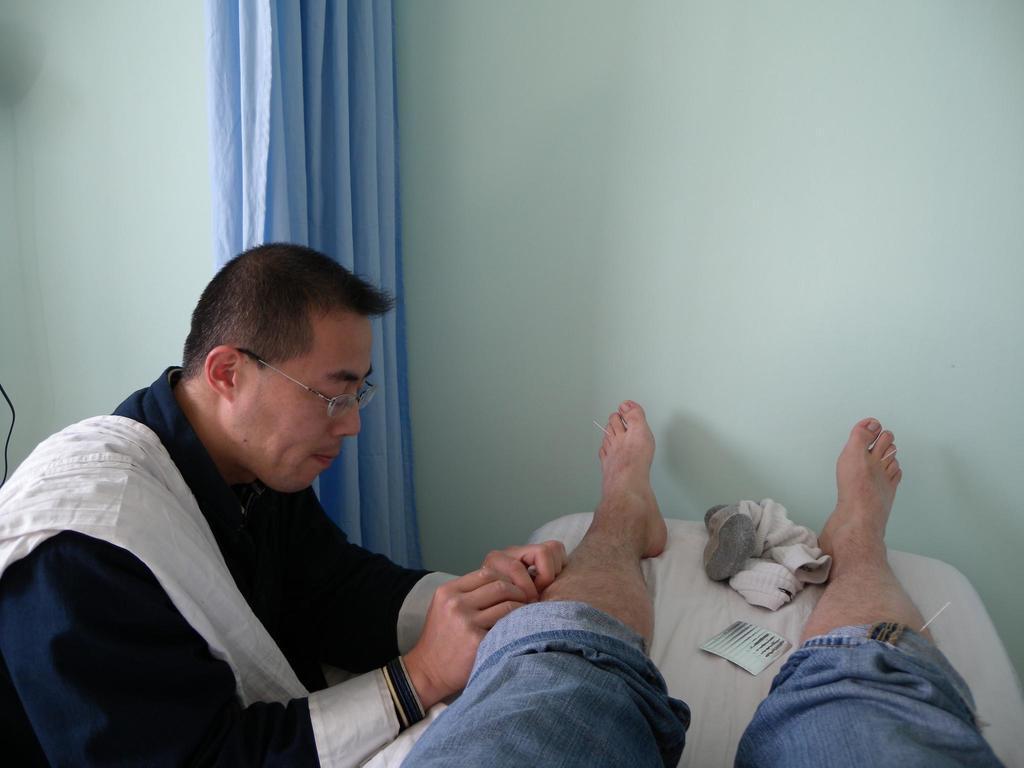How would you summarize this image in a sentence or two? In the image we can see there is a person lying on the bed and there is another person sitting on the chair. Behind there is a blue curtain. 